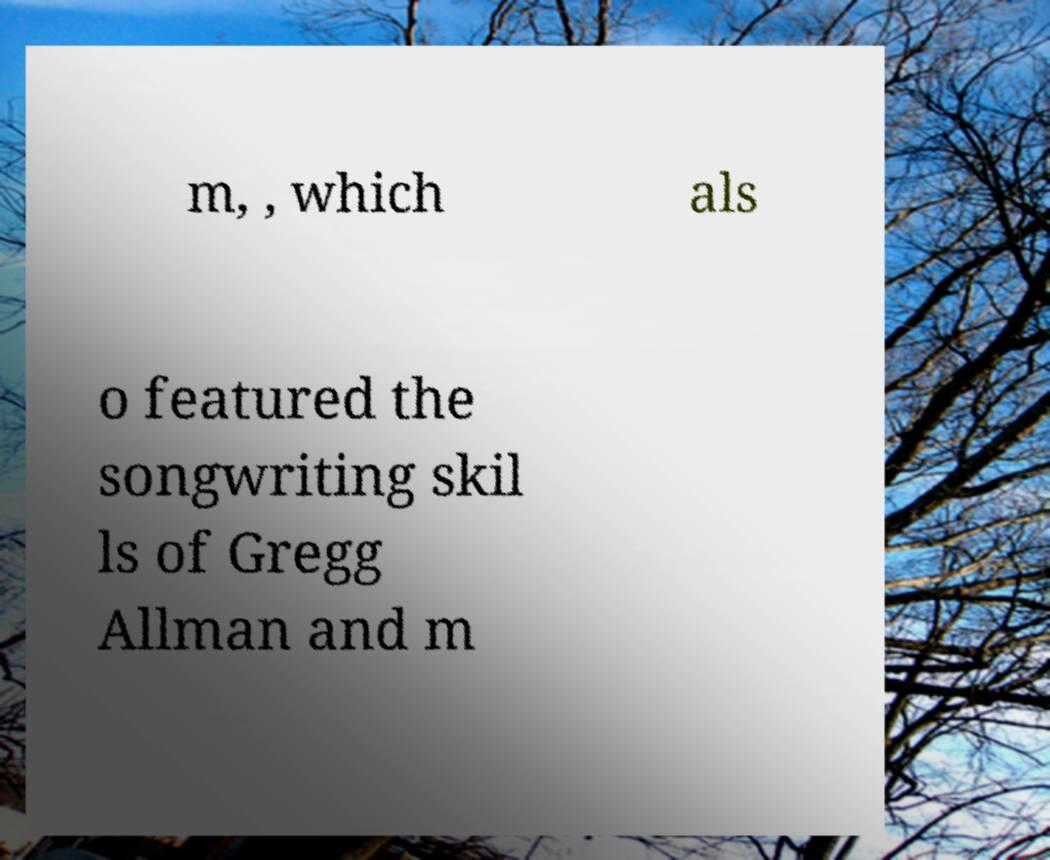Please read and relay the text visible in this image. What does it say? m, , which als o featured the songwriting skil ls of Gregg Allman and m 